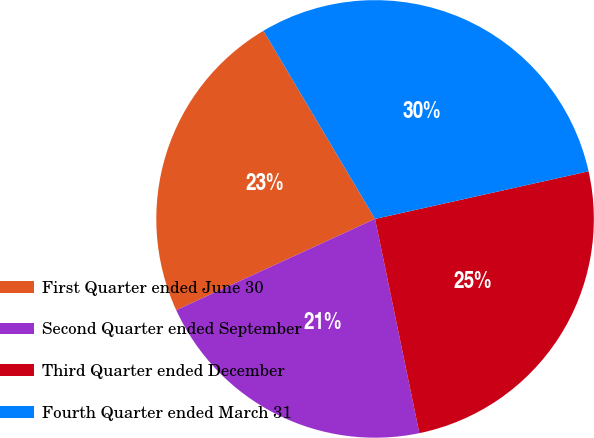Convert chart. <chart><loc_0><loc_0><loc_500><loc_500><pie_chart><fcel>First Quarter ended June 30<fcel>Second Quarter ended September<fcel>Third Quarter ended December<fcel>Fourth Quarter ended March 31<nl><fcel>23.32%<fcel>21.4%<fcel>25.25%<fcel>30.03%<nl></chart> 